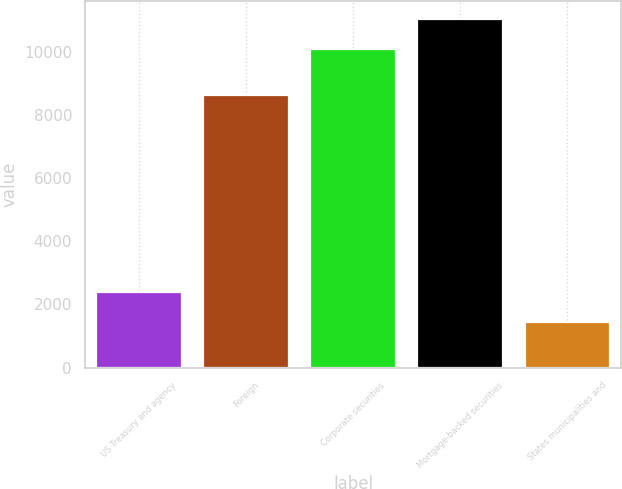<chart> <loc_0><loc_0><loc_500><loc_500><bar_chart><fcel>US Treasury and agency<fcel>Foreign<fcel>Corporate securities<fcel>Mortgage-backed securities<fcel>States municipalities and<nl><fcel>2393.6<fcel>8625<fcel>10093<fcel>11044.6<fcel>1442<nl></chart> 